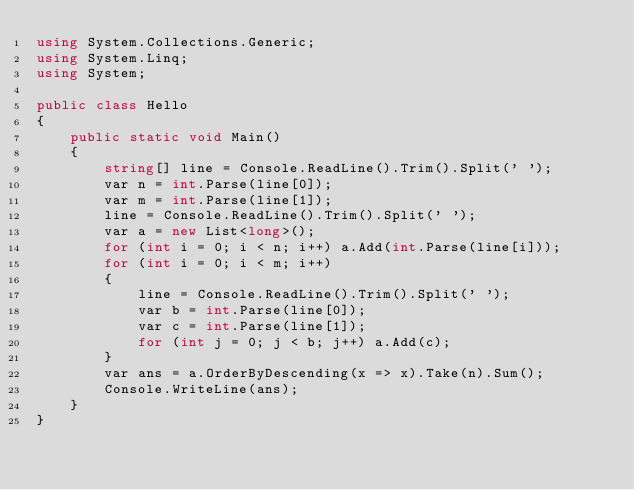Convert code to text. <code><loc_0><loc_0><loc_500><loc_500><_C#_>using System.Collections.Generic;
using System.Linq;
using System;

public class Hello
{
	public static void Main()
	{
		string[] line = Console.ReadLine().Trim().Split(' ');
		var n = int.Parse(line[0]);
		var m = int.Parse(line[1]);
		line = Console.ReadLine().Trim().Split(' ');
		var a = new List<long>();
		for (int i = 0; i < n; i++) a.Add(int.Parse(line[i]));
		for (int i = 0; i < m; i++)
		{
			line = Console.ReadLine().Trim().Split(' ');
			var b = int.Parse(line[0]);
			var c = int.Parse(line[1]);
			for (int j = 0; j < b; j++) a.Add(c);
		}
		var ans = a.OrderByDescending(x => x).Take(n).Sum();
		Console.WriteLine(ans);
	}
}</code> 